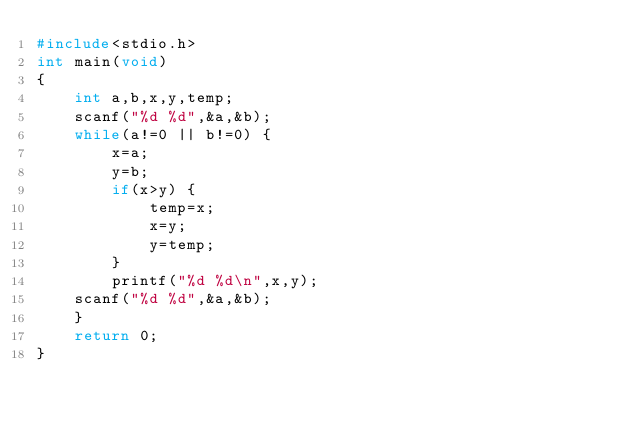Convert code to text. <code><loc_0><loc_0><loc_500><loc_500><_C_>#include<stdio.h>
int main(void)
{
	int a,b,x,y,temp;
	scanf("%d %d",&a,&b);
	while(a!=0 || b!=0) {
		x=a;
		y=b;
		if(x>y) {
			temp=x;
			x=y;
			y=temp;
		}
		printf("%d %d\n",x,y);
	scanf("%d %d",&a,&b);
	}
	return 0;
}</code> 